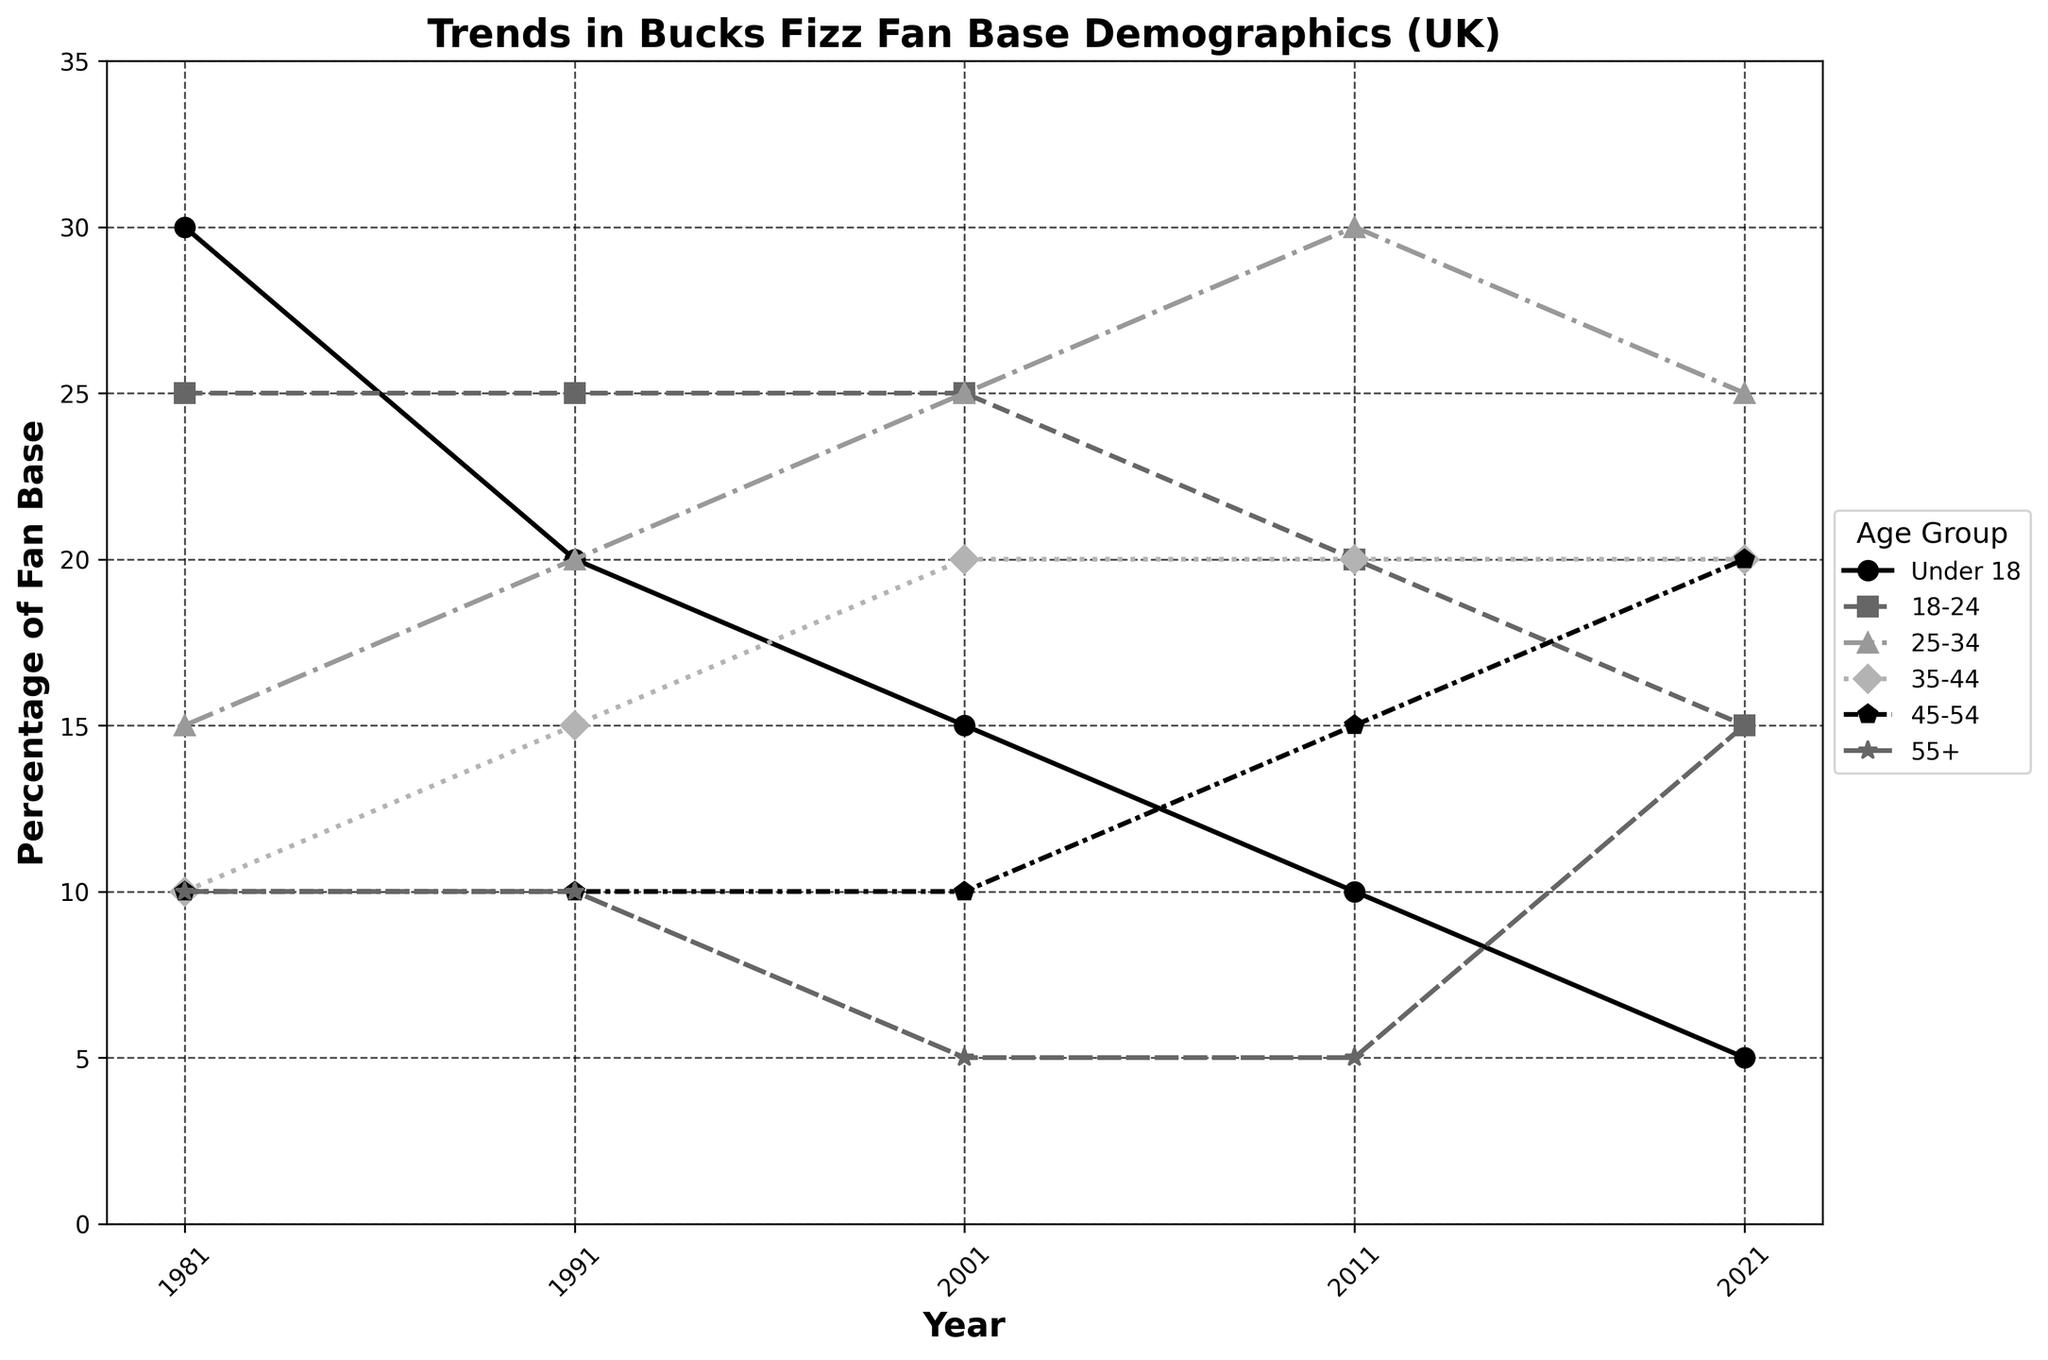What's the title of the figure? The title is usually located at the top of the figure. By looking at this area, the title can be read directly.
Answer: Trends in Bucks Fizz Fan Base Demographics (UK) What is the percentage of fans aged 25-34 in 2021? Locate the year 2021 on the x-axis and follow it vertically to the data point corresponding to the age group 25-34.
Answer: 25% How does the percentage of fans under 18 change from 1981 to 2021? Identify the data points for the age group "Under 18" in both 1981 and 2021 and note the change in values. In 1981, it's 30%. In 2021, it's 5%. So, the percentage decreases from 30% to 5%.
Answer: Decreases from 30% to 5% Which age group shows the highest percentage in 2011? Locate the year 2011 on the x-axis and find the highest data point by comparing the percentages of all age groups in that year. The highest data point is at 30% for the age group 25-34.
Answer: 25-34 Between which decades did the percentage of fans aged 55+ remain constant and when did it increase? Review the trend for the age group "55+" over the different decades. The percentage remains at 10% from 1981 to 2001 and then decreases to 5% by 2011, followed by an increase to 15% in 2021.
Answer: 1981-2001 (constant), increases from 2011 to 2021 What are the x-axis and y-axis labels in the figure? The x-axis label is found along the horizontal axis and the y-axis label is found along the vertical axis.
Answer: Year (x-axis), Percentage of Fan Base (y-axis) By how much did the percentage of fans aged 35-44 change from 2001 to 2021? Identify the values for the age group 35-44 in 2001 and 2021. The values are 20% in both years. Calculate the difference: 20% - 20% = 0%. The percentage did not change.
Answer: 0% Which age group had the most significant decrease in percentage of fan base between 1981 and 2021? Compare the changes across all age groups from 1981 to 2021. The age group "Under 18" decreased from 30% to 5%, a significant decrease of 25%.
Answer: Under 18 How many age groups had a percentage of fan base equal to 10% in 1981? Look at the values for each age group in the year 1981 and sum up the instances where the percentage is 10%. There are three age groups: 35-44, 45-54, and 55+.
Answer: 3 Which age group shows a continuous increase in percentage from 1981 to 2021? Review the trend lines for each age group across the years. The age group "45-54" shows an increase from 10% in 1981 to 20% in 2021 continuously without any dip.
Answer: 45-54 